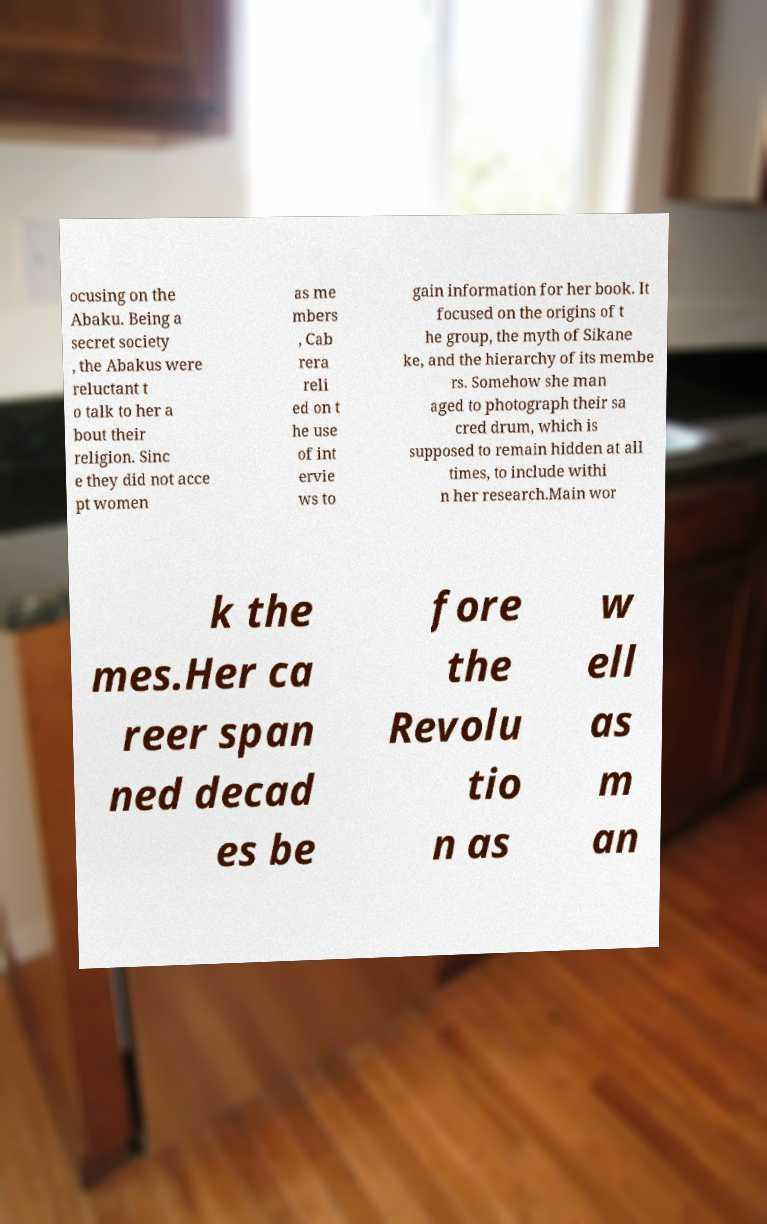Can you read and provide the text displayed in the image?This photo seems to have some interesting text. Can you extract and type it out for me? ocusing on the Abaku. Being a secret society , the Abakus were reluctant t o talk to her a bout their religion. Sinc e they did not acce pt women as me mbers , Cab rera reli ed on t he use of int ervie ws to gain information for her book. It focused on the origins of t he group, the myth of Sikane ke, and the hierarchy of its membe rs. Somehow she man aged to photograph their sa cred drum, which is supposed to remain hidden at all times, to include withi n her research.Main wor k the mes.Her ca reer span ned decad es be fore the Revolu tio n as w ell as m an 